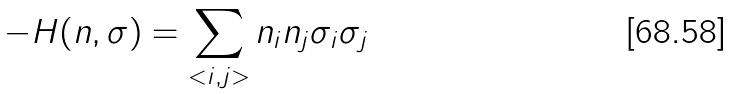<formula> <loc_0><loc_0><loc_500><loc_500>- H ( n , \sigma ) = \sum _ { < i , j > } n _ { i } n _ { j } \sigma _ { i } \sigma _ { j }</formula> 